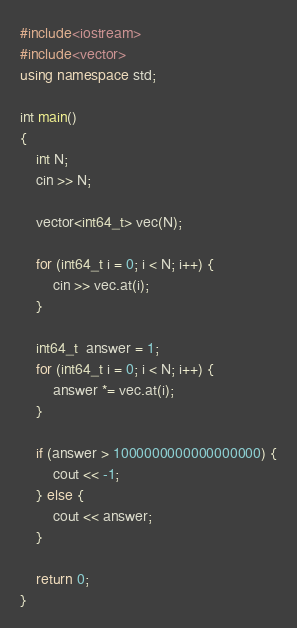Convert code to text. <code><loc_0><loc_0><loc_500><loc_500><_C++_>#include<iostream>
#include<vector>
using namespace std;

int main()
{
    int N;
    cin >> N;

    vector<int64_t> vec(N);

    for (int64_t i = 0; i < N; i++) {
        cin >> vec.at(i);
    }

    int64_t  answer = 1;
    for (int64_t i = 0; i < N; i++) {
        answer *= vec.at(i);
    }

    if (answer > 1000000000000000000) {
        cout << -1; 
    } else {
        cout << answer;
    }

    return 0;
}</code> 